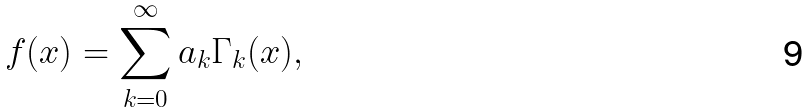<formula> <loc_0><loc_0><loc_500><loc_500>f ( x ) = \sum _ { k = 0 } ^ { \infty } a _ { k } \Gamma _ { k } ( x ) ,</formula> 